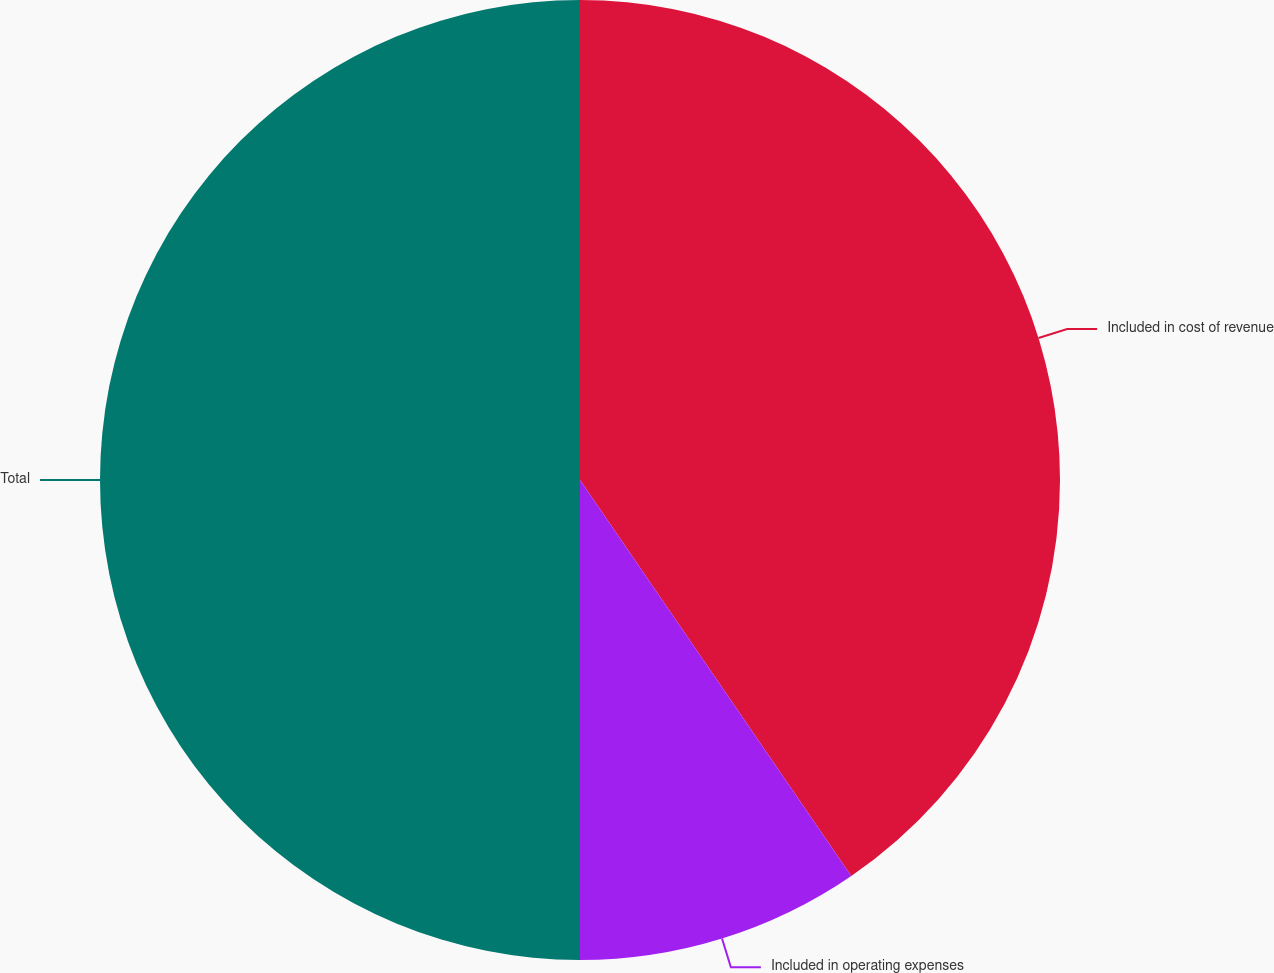Convert chart. <chart><loc_0><loc_0><loc_500><loc_500><pie_chart><fcel>Included in cost of revenue<fcel>Included in operating expenses<fcel>Total<nl><fcel>40.44%<fcel>9.56%<fcel>50.0%<nl></chart> 